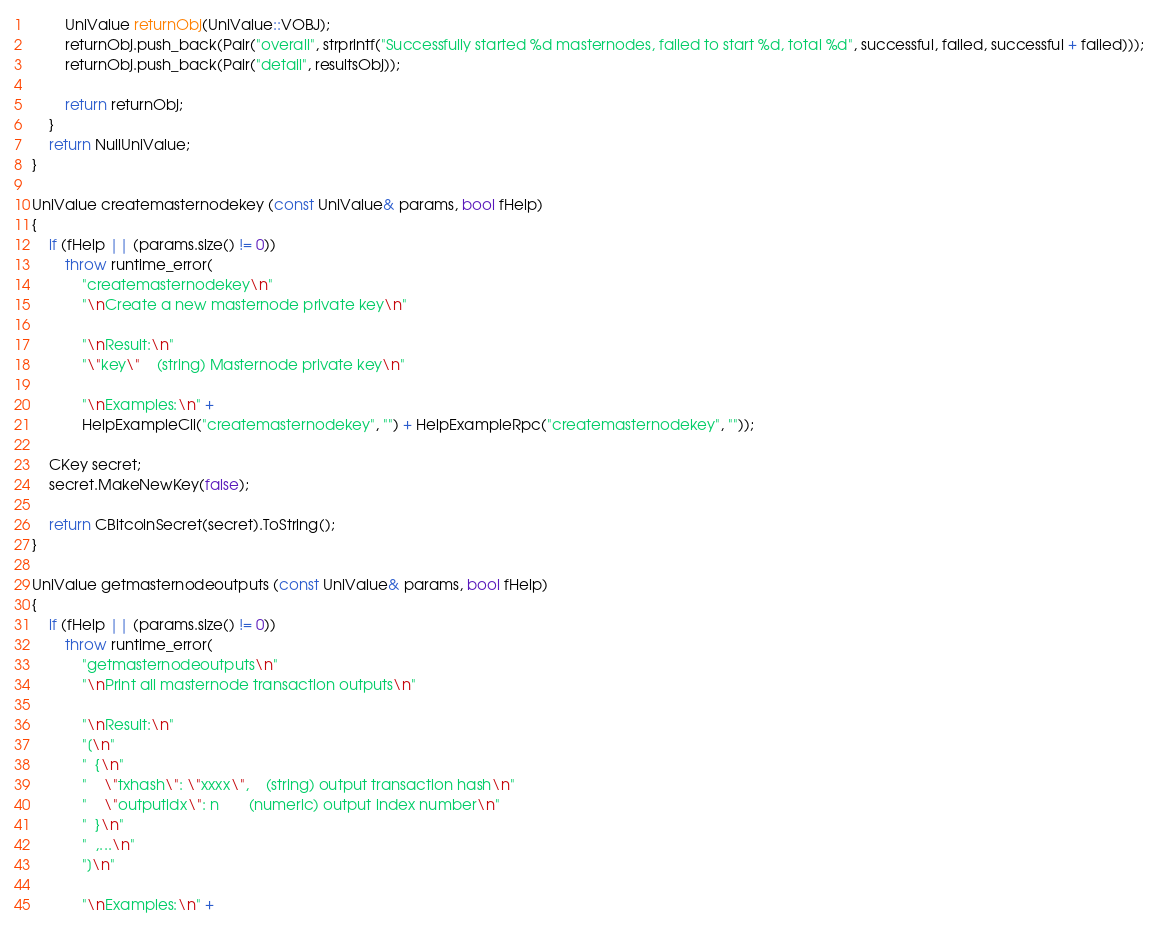Convert code to text. <code><loc_0><loc_0><loc_500><loc_500><_C++_>        UniValue returnObj(UniValue::VOBJ);
        returnObj.push_back(Pair("overall", strprintf("Successfully started %d masternodes, failed to start %d, total %d", successful, failed, successful + failed)));
        returnObj.push_back(Pair("detail", resultsObj));

        return returnObj;
    }
    return NullUniValue;
}

UniValue createmasternodekey (const UniValue& params, bool fHelp)
{
    if (fHelp || (params.size() != 0))
        throw runtime_error(
            "createmasternodekey\n"
            "\nCreate a new masternode private key\n"

            "\nResult:\n"
            "\"key\"    (string) Masternode private key\n"

            "\nExamples:\n" +
            HelpExampleCli("createmasternodekey", "") + HelpExampleRpc("createmasternodekey", ""));

    CKey secret;
    secret.MakeNewKey(false);

    return CBitcoinSecret(secret).ToString();
}

UniValue getmasternodeoutputs (const UniValue& params, bool fHelp)
{
    if (fHelp || (params.size() != 0))
        throw runtime_error(
            "getmasternodeoutputs\n"
            "\nPrint all masternode transaction outputs\n"

            "\nResult:\n"
            "[\n"
            "  {\n"
            "    \"txhash\": \"xxxx\",    (string) output transaction hash\n"
            "    \"outputidx\": n       (numeric) output index number\n"
            "  }\n"
            "  ,...\n"
            "]\n"

            "\nExamples:\n" +</code> 